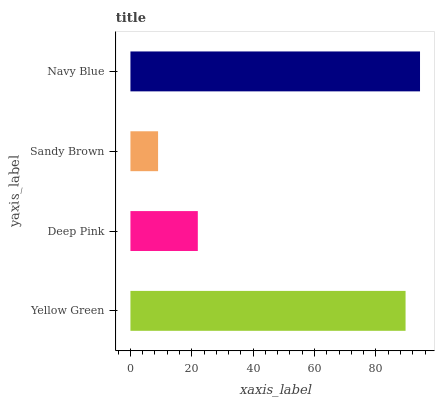Is Sandy Brown the minimum?
Answer yes or no. Yes. Is Navy Blue the maximum?
Answer yes or no. Yes. Is Deep Pink the minimum?
Answer yes or no. No. Is Deep Pink the maximum?
Answer yes or no. No. Is Yellow Green greater than Deep Pink?
Answer yes or no. Yes. Is Deep Pink less than Yellow Green?
Answer yes or no. Yes. Is Deep Pink greater than Yellow Green?
Answer yes or no. No. Is Yellow Green less than Deep Pink?
Answer yes or no. No. Is Yellow Green the high median?
Answer yes or no. Yes. Is Deep Pink the low median?
Answer yes or no. Yes. Is Deep Pink the high median?
Answer yes or no. No. Is Navy Blue the low median?
Answer yes or no. No. 